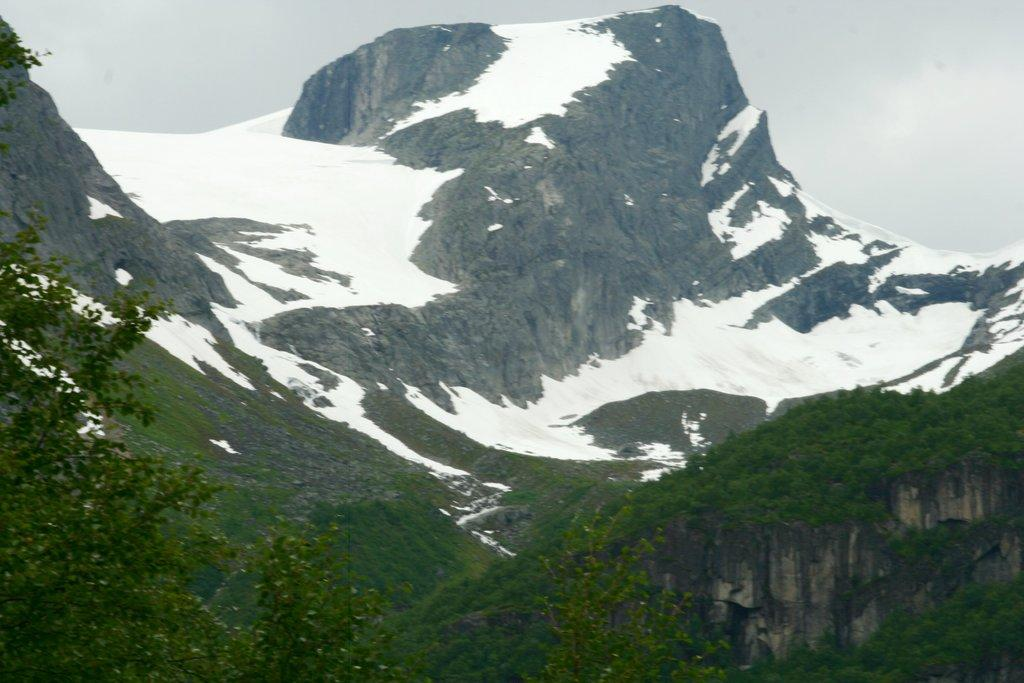What type of vegetation can be seen in the image? There are trees in the image. What is covering the trees in the image? The trees are covered with snow. What geographical features are visible in the image? There are mountains in the image. What is covering the mountains in the image? The mountains are covered with snow. Can you see an example of a cart being used to transport snow in the image? There is no cart present in the image, and therefore no such activity can be observed. 